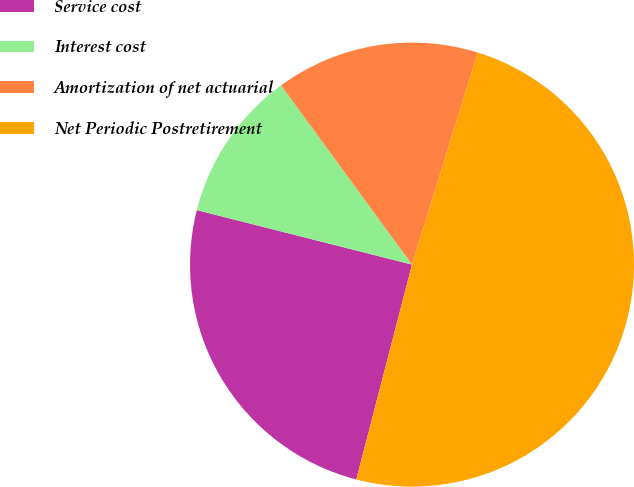<chart> <loc_0><loc_0><loc_500><loc_500><pie_chart><fcel>Service cost<fcel>Interest cost<fcel>Amortization of net actuarial<fcel>Net Periodic Postretirement<nl><fcel>24.91%<fcel>11.01%<fcel>14.83%<fcel>49.25%<nl></chart> 